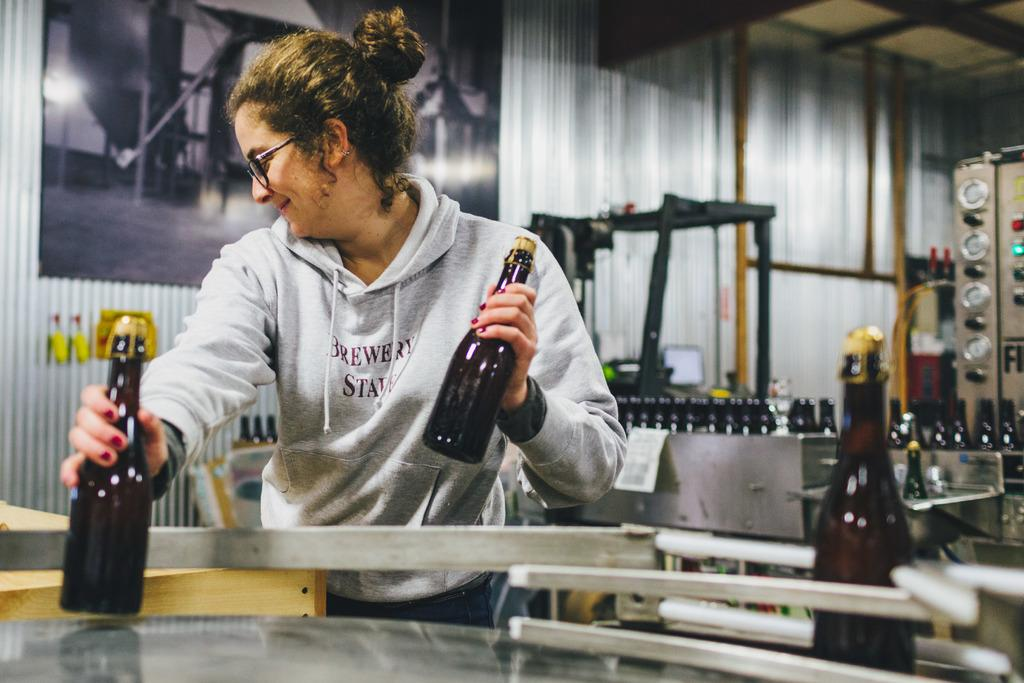Who is present in the image? There is a woman in the image. What is the woman holding in the image? The woman is holding two bottles. What is the woman's facial expression in the image? The woman is smiling. What accessory is the woman wearing in the image? The woman is wearing glasses (specs). What type of pancake is the woman flipping in the image? There is no pancake present in the image; the woman is holding two bottles. 